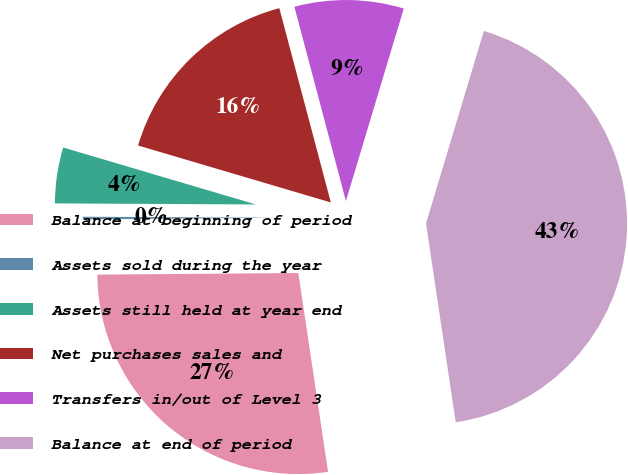Convert chart to OTSL. <chart><loc_0><loc_0><loc_500><loc_500><pie_chart><fcel>Balance at beginning of period<fcel>Assets sold during the year<fcel>Assets still held at year end<fcel>Net purchases sales and<fcel>Transfers in/out of Level 3<fcel>Balance at end of period<nl><fcel>27.23%<fcel>0.21%<fcel>4.49%<fcel>16.3%<fcel>8.77%<fcel>42.99%<nl></chart> 